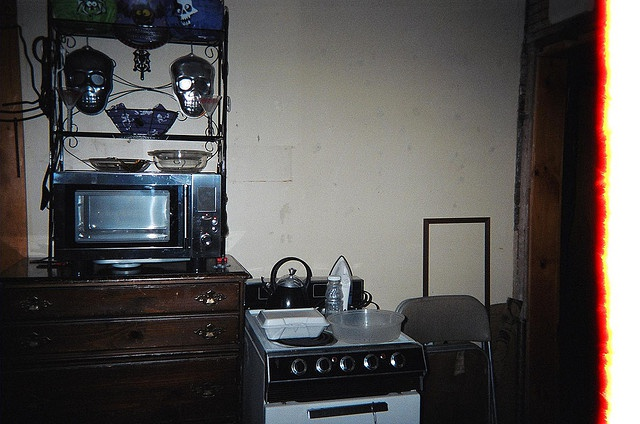Describe the objects in this image and their specific colors. I can see microwave in black, gray, and blue tones, oven in black, gray, and darkgray tones, chair in black and gray tones, bowl in black, gray, darkblue, and darkgray tones, and bowl in black, gray, darkgray, and lightgray tones in this image. 